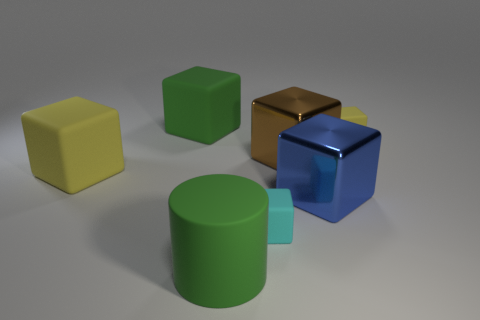Add 1 big green shiny cylinders. How many objects exist? 8 Subtract all cyan blocks. How many blocks are left? 5 Subtract all large cubes. How many cubes are left? 2 Subtract all cylinders. How many objects are left? 6 Add 1 small blue metal objects. How many small blue metal objects exist? 1 Subtract 1 green cubes. How many objects are left? 6 Subtract 2 blocks. How many blocks are left? 4 Subtract all brown cylinders. Subtract all green balls. How many cylinders are left? 1 Subtract all blue blocks. How many blue cylinders are left? 0 Subtract all tiny blocks. Subtract all small yellow objects. How many objects are left? 4 